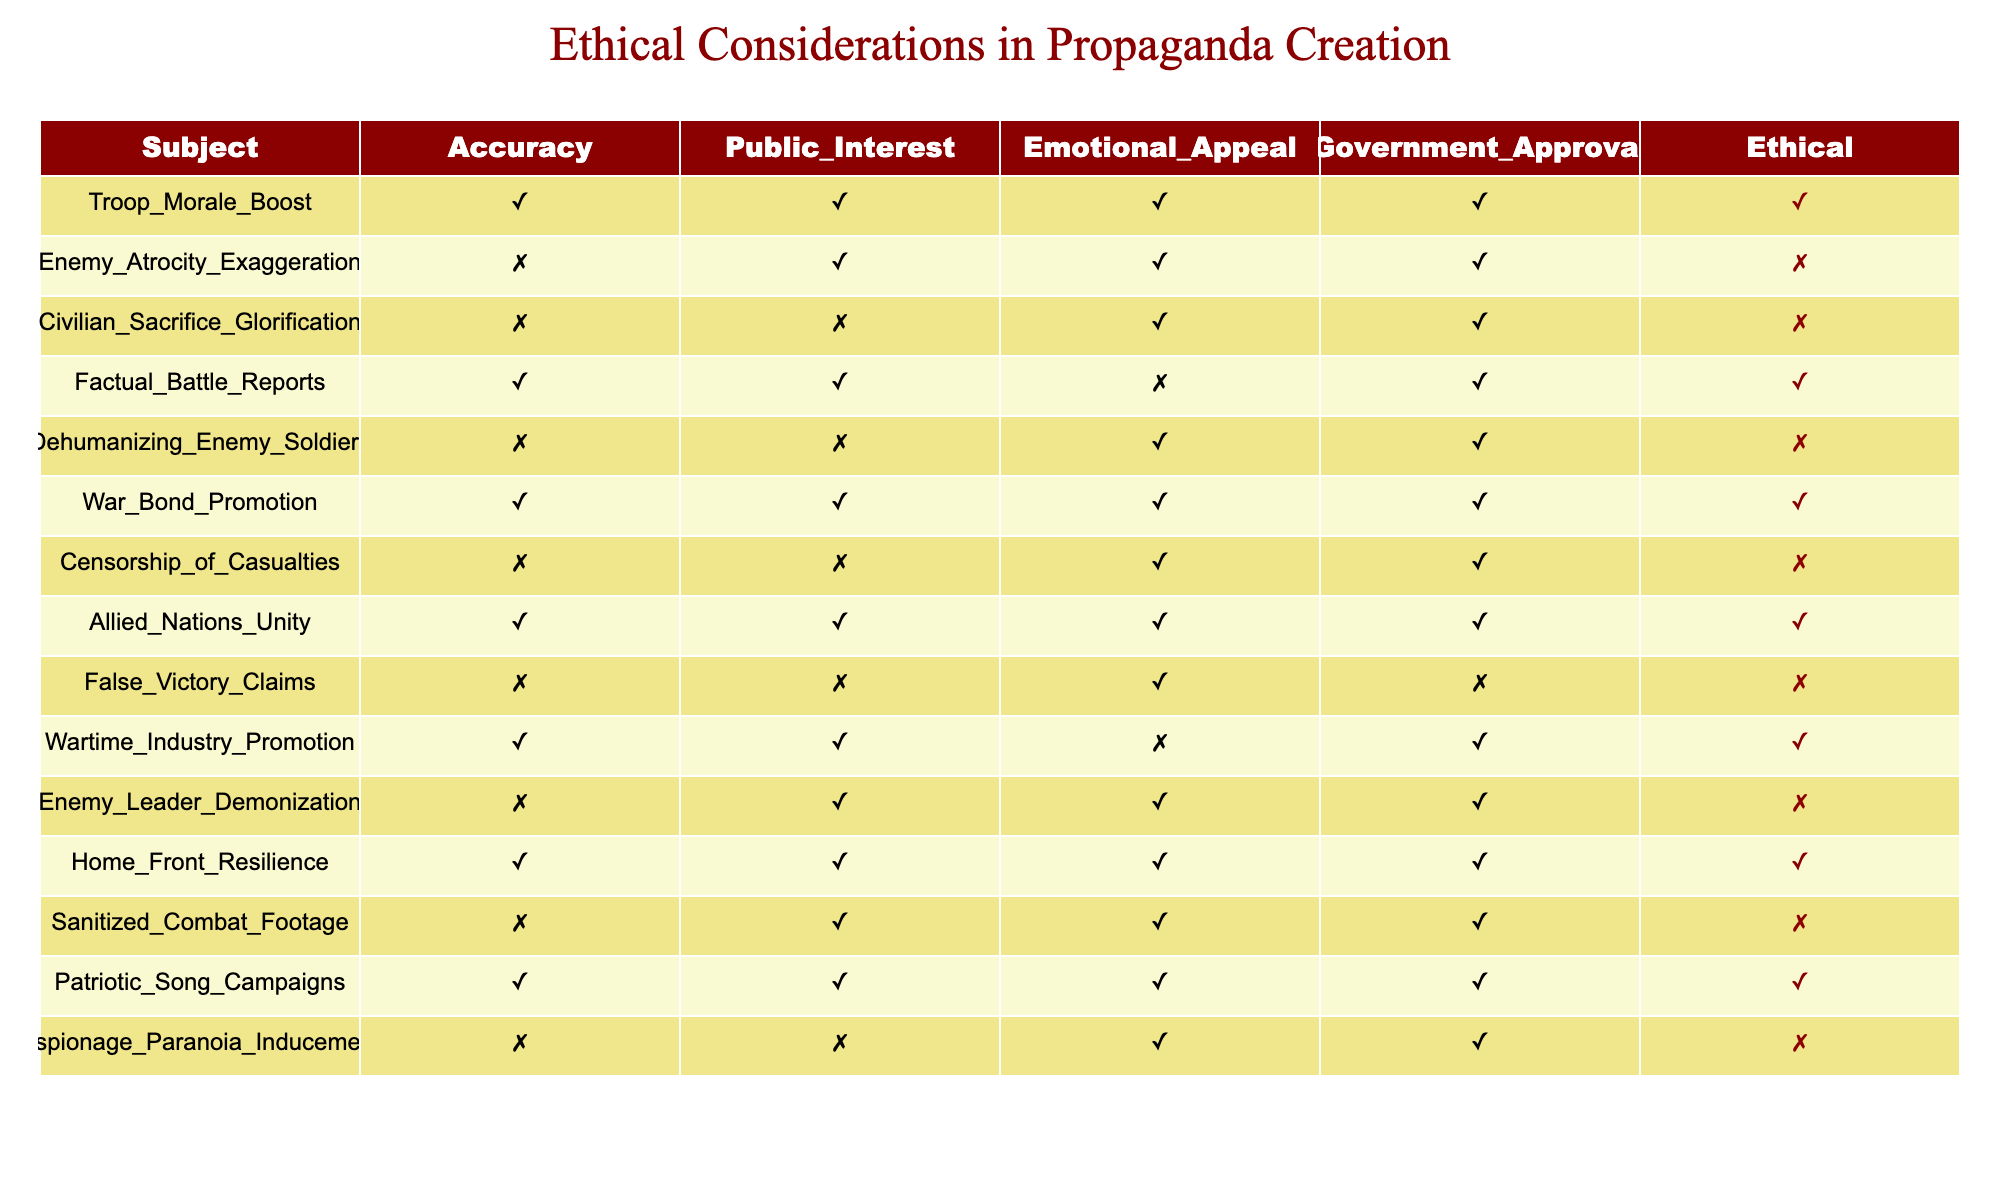What are the ethical considerations for "Civilian Sacrifice Glorification"? Referring to the table, the ethical column shows "FALSE" for "Civilian Sacrifice Glorification," indicating it is considered unethical.
Answer: FALSE How many propaganda subjects have emotional appeal (TRUE)? By counting the rows where Emotional Appeal is TRUE, we find 7 instances: Troop Morale Boost, Enemy Atrocity Exaggeration, Civilian Sacrifice Glorification, War Bond Promotion, Allied Nations Unity, Home Front Resilience, and Patriotic Song Campaigns.
Answer: 7 Is "Censorship of Casualties" deemed ethical? Looking at the ethical column for "Censorship of Casualties," it is marked as FALSE, indicating it is not considered ethical.
Answer: FALSE Which subject has both Government Approval and is Ethical? We can check the rows in the table where both Government Approval and Ethical are TRUE. The entries are Troop Morale Boost, Factual Battle Reports, War Bond Promotion, Allied Nations Unity, Home Front Resilience, and Patriotic Song Campaigns. Among these, all listed are valid subjects that meet the criteria, and they include five subjects.
Answer: 5 subjects What percentage of propaganda subjects are ethical? Out of the total 15 subjects, 8 are marked as Ethical (TRUE). To find the percentage, we calculate (8/15) * 100 = 53.33%.
Answer: 53.33% Which propaganda subject promotes wartime unity while being ethical? According to the table, "Allied Nations Unity" is listed with TRUE for both Ethical and Public Interest, making it a valid example of promoting wartime unity ethically.
Answer: Allied Nations Unity What is the ratio of ethical to non-ethical subjects in this table? There are 8 Ethical subjects and 7 Non-Ethical subjects. The ratio of ethical to non-ethical is 8:7, representing the ethical considerations in propaganda creation.
Answer: 8:7 Does “Enemy Leader Demonization” have public interest? Looking at the Public Interest column for "Enemy Leader Demonization," it is marked as TRUE, indicating that it does have public interest.
Answer: TRUE 